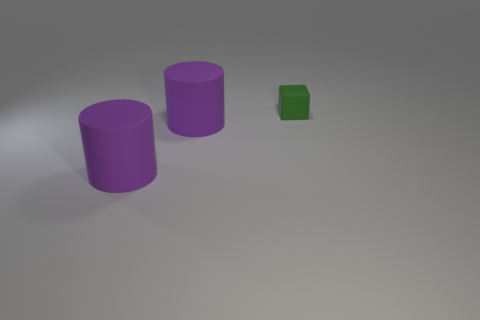Add 1 big things. How many objects exist? 4 Subtract 2 cylinders. How many cylinders are left? 0 Subtract all matte cylinders. Subtract all tiny rubber cubes. How many objects are left? 0 Add 1 purple rubber cylinders. How many purple rubber cylinders are left? 3 Add 3 big brown cylinders. How many big brown cylinders exist? 3 Subtract 0 brown cylinders. How many objects are left? 3 Subtract all cylinders. How many objects are left? 1 Subtract all purple cubes. Subtract all blue balls. How many cubes are left? 1 Subtract all purple spheres. How many red cylinders are left? 0 